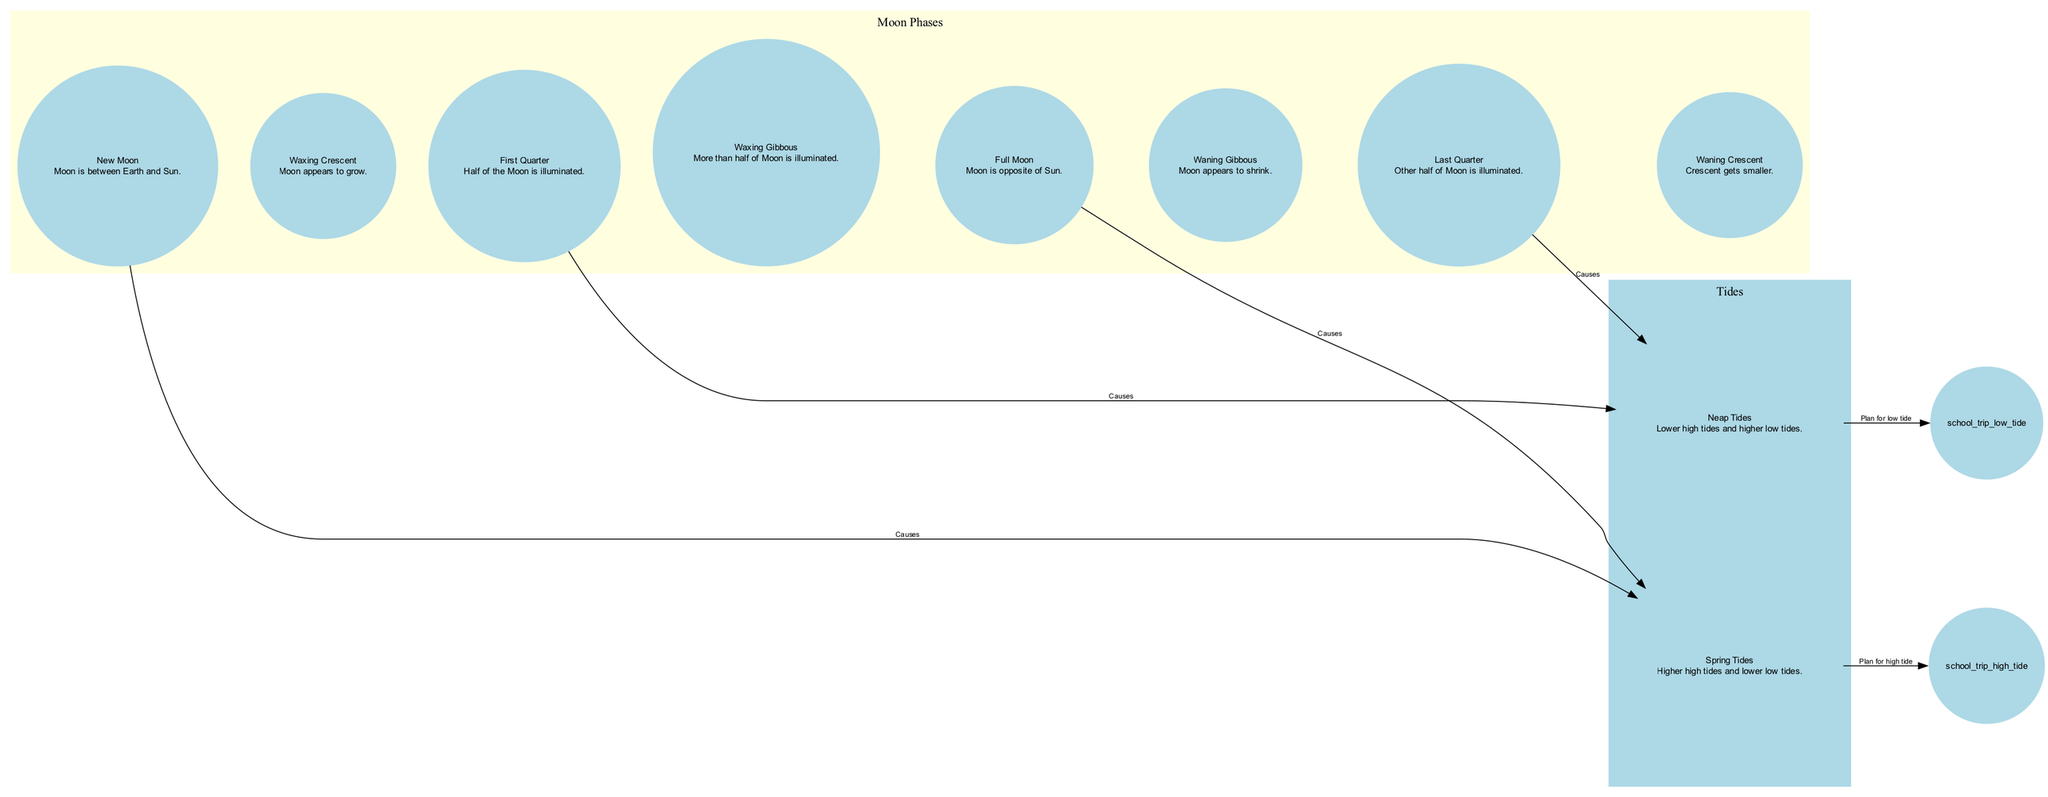What causes spring tides? Spring tides are caused by both the new moon and full moon phases, as indicated by the edges connecting these nodes to the spring tides node.
Answer: New Moon and Full Moon What is the description of the waxing gibbous phase? The description of the waxing gibbous phase is "More than half of Moon is illuminated," according to the node labeled "Waxing Gibbous."
Answer: More than half of Moon is illuminated How many phases of the moon are represented in the diagram? The diagram represents eight phases of the moon, which can be counted from the nodes specifically listed as moon phases.
Answer: Eight Which moon phases lead to neap tides? The last quarter and first quarter phases cause neap tides, as shown by the edges connecting these phases to the neap tides node.
Answer: Last Quarter and First Quarter What type of tide occurs during a new moon? During a new moon, spring tides occur, which is indicated by the edge that connects the new moon node to the spring tides node.
Answer: Spring Tides What should we plan for during spring tides when scheduling a school trip? For spring tides, the plan should focus on high tide, as indicated by the edge connecting spring tides to the school trip high tide node.
Answer: Plan for high tide What happens during the waxing crescent phase? During the waxing crescent phase, the moon appears to grow, as stated in the description associated with the waxing crescent node.
Answer: Moon appears to grow Which tide has lower high tides and higher low tides? The neap tides have lower high tides and higher low tides, as described in the node labeled "Neap Tides."
Answer: Neap Tides 